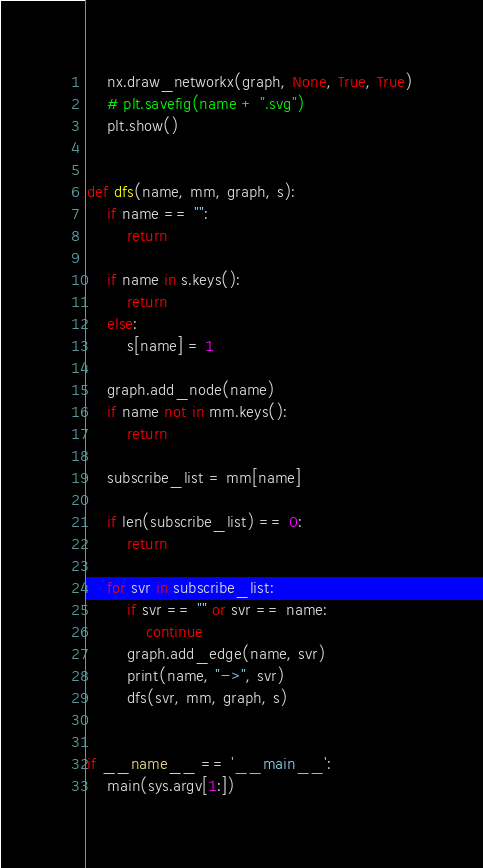<code> <loc_0><loc_0><loc_500><loc_500><_Python_>    nx.draw_networkx(graph, None, True, True)
    # plt.savefig(name + ".svg")
    plt.show()


def dfs(name, mm, graph, s):
    if name == "":
        return

    if name in s.keys():
        return
    else:
        s[name] = 1

    graph.add_node(name)
    if name not in mm.keys():
        return

    subscribe_list = mm[name]

    if len(subscribe_list) == 0:
        return

    for svr in subscribe_list:
        if svr == "" or svr == name:
            continue
        graph.add_edge(name, svr)
        print(name, "->", svr)
        dfs(svr, mm, graph, s)


if __name__ == '__main__':
    main(sys.argv[1:])
</code> 